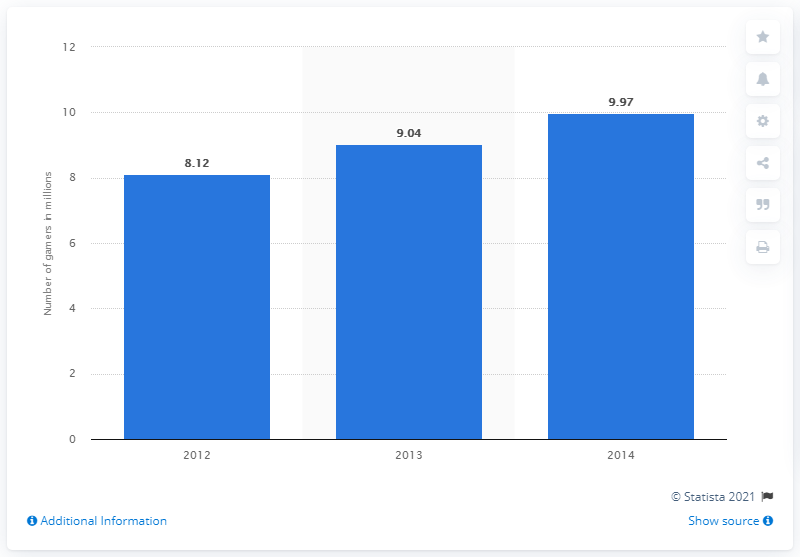Give some essential details in this illustration. The value of 2013 is 9.04. There were 8.12 million online gamers in Thailand in 2012. The sum of all the blue bars is 27.13. According to projections, the number of online gamers in Thailand in 2014 was expected to be approximately 9.97 million. 